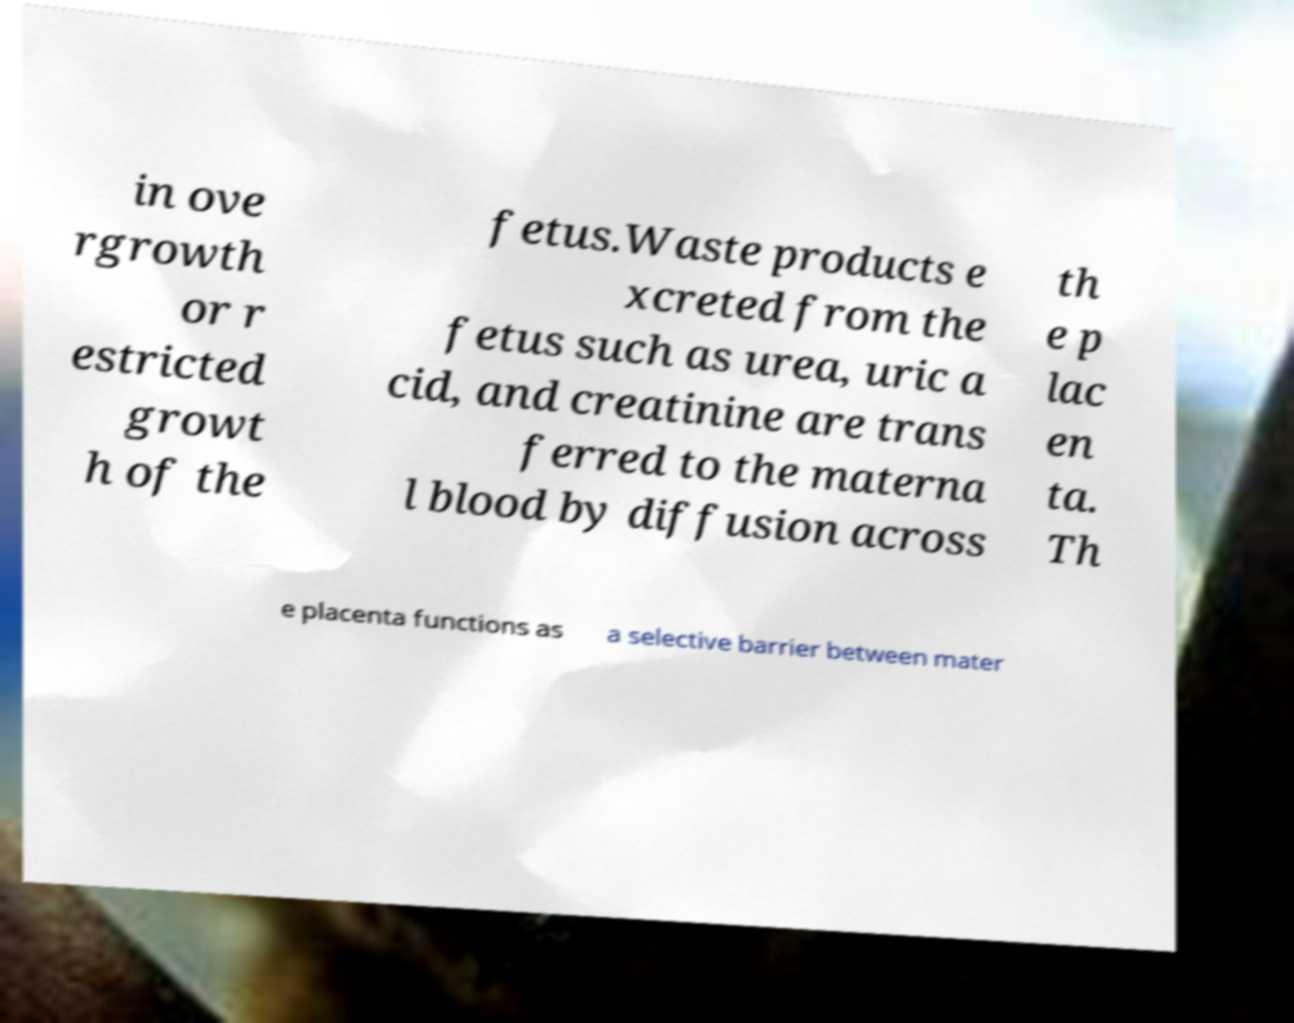For documentation purposes, I need the text within this image transcribed. Could you provide that? in ove rgrowth or r estricted growt h of the fetus.Waste products e xcreted from the fetus such as urea, uric a cid, and creatinine are trans ferred to the materna l blood by diffusion across th e p lac en ta. Th e placenta functions as a selective barrier between mater 